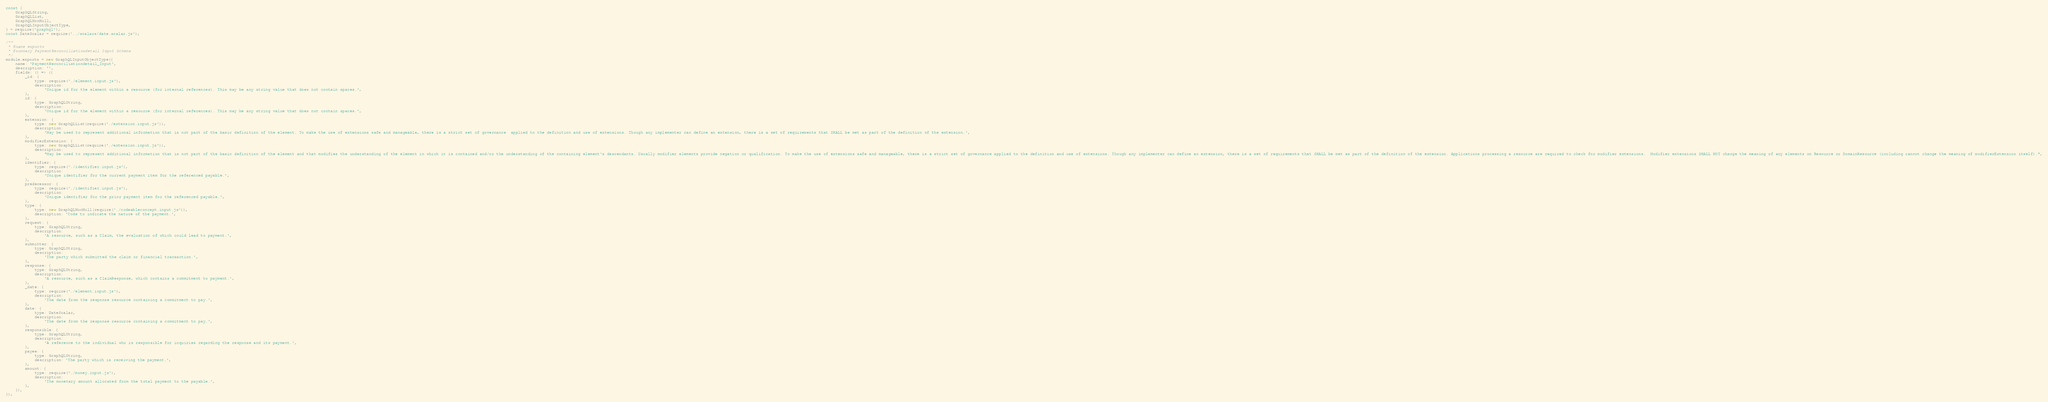<code> <loc_0><loc_0><loc_500><loc_500><_JavaScript_>const {
	GraphQLString,
	GraphQLList,
	GraphQLNonNull,
	GraphQLInputObjectType,
} = require('graphql');
const DateScalar = require('../scalars/date.scalar.js');

/**
 * @name exports
 * @summary PaymentReconciliationdetail Input Schema
 */
module.exports = new GraphQLInputObjectType({
	name: 'PaymentReconciliationdetail_Input',
	description: '',
	fields: () => ({
		_id: {
			type: require('./element.input.js'),
			description:
				'Unique id for the element within a resource (for internal references). This may be any string value that does not contain spaces.',
		},
		id: {
			type: GraphQLString,
			description:
				'Unique id for the element within a resource (for internal references). This may be any string value that does not contain spaces.',
		},
		extension: {
			type: new GraphQLList(require('./extension.input.js')),
			description:
				'May be used to represent additional information that is not part of the basic definition of the element. To make the use of extensions safe and manageable, there is a strict set of governance  applied to the definition and use of extensions. Though any implementer can define an extension, there is a set of requirements that SHALL be met as part of the definition of the extension.',
		},
		modifierExtension: {
			type: new GraphQLList(require('./extension.input.js')),
			description:
				"May be used to represent additional information that is not part of the basic definition of the element and that modifies the understanding of the element in which it is contained and/or the understanding of the containing element's descendants. Usually modifier elements provide negation or qualification. To make the use of extensions safe and manageable, there is a strict set of governance applied to the definition and use of extensions. Though any implementer can define an extension, there is a set of requirements that SHALL be met as part of the definition of the extension. Applications processing a resource are required to check for modifier extensions.  Modifier extensions SHALL NOT change the meaning of any elements on Resource or DomainResource (including cannot change the meaning of modifierExtension itself).",
		},
		identifier: {
			type: require('./identifier.input.js'),
			description:
				'Unique identifier for the current payment item for the referenced payable.',
		},
		predecessor: {
			type: require('./identifier.input.js'),
			description:
				'Unique identifier for the prior payment item for the referenced payable.',
		},
		type: {
			type: new GraphQLNonNull(require('./codeableconcept.input.js')),
			description: 'Code to indicate the nature of the payment.',
		},
		request: {
			type: GraphQLString,
			description:
				'A resource, such as a Claim, the evaluation of which could lead to payment.',
		},
		submitter: {
			type: GraphQLString,
			description:
				'The party which submitted the claim or financial transaction.',
		},
		response: {
			type: GraphQLString,
			description:
				'A resource, such as a ClaimResponse, which contains a commitment to payment.',
		},
		_date: {
			type: require('./element.input.js'),
			description:
				'The date from the response resource containing a commitment to pay.',
		},
		date: {
			type: DateScalar,
			description:
				'The date from the response resource containing a commitment to pay.',
		},
		responsible: {
			type: GraphQLString,
			description:
				'A reference to the individual who is responsible for inquiries regarding the response and its payment.',
		},
		payee: {
			type: GraphQLString,
			description: 'The party which is receiving the payment.',
		},
		amount: {
			type: require('./money.input.js'),
			description:
				'The monetary amount allocated from the total payment to the payable.',
		},
	}),
});
</code> 